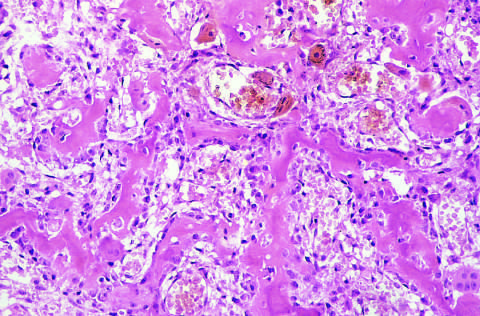what are filled by vascularized loose connective tissue?
Answer the question using a single word or phrase. The intertrabecular spaces 